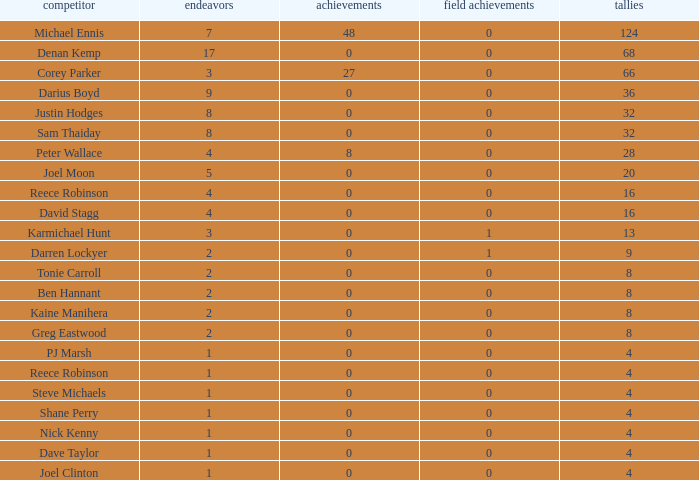What is the number of goals Dave Taylor, who has more than 1 tries, has? None. 